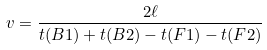Convert formula to latex. <formula><loc_0><loc_0><loc_500><loc_500>v = \frac { 2 \ell } { t ( B 1 ) + t ( B 2 ) - t ( F 1 ) - t ( F 2 ) }</formula> 